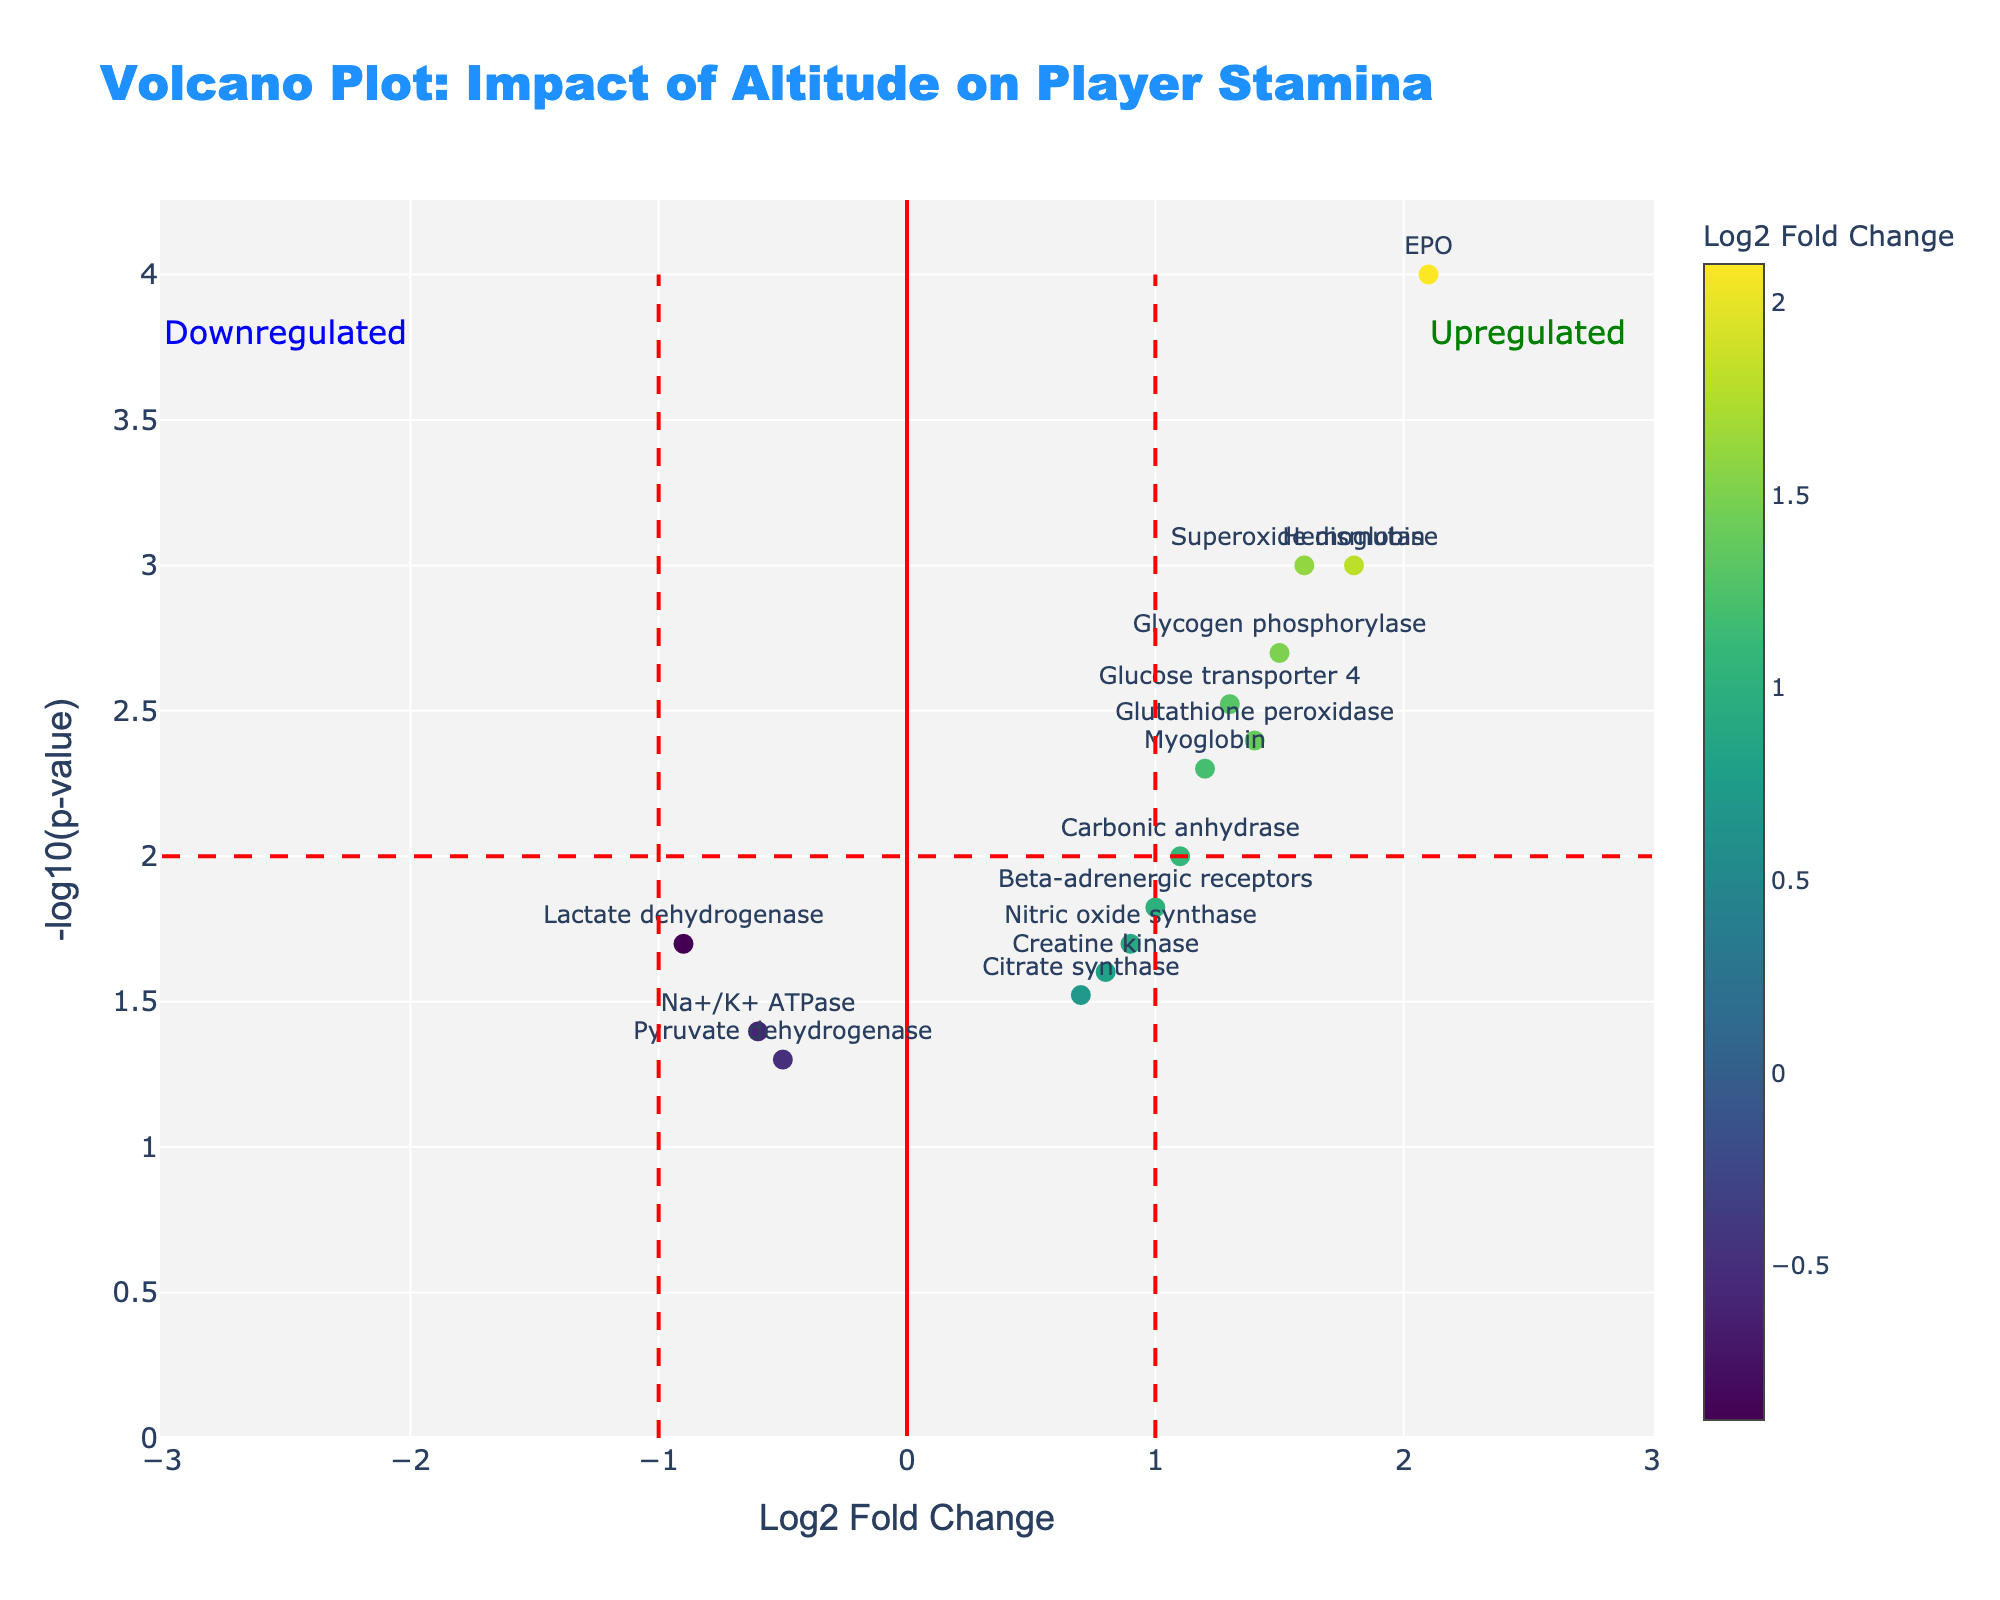Which gene has the highest log2 fold change? To identify the gene with the highest log2 fold change, look for the data point that is farthest to the right on the x-axis. The gene with the highest value is EPO with a log2 fold change of 2.1.
Answer: EPO How many genes are significantly upregulated? Genes are considered significantly upregulated if they are on the right side of the vertical significance line (log2 fold change > 1) and above the horizontal significance line (-log10(p-value) > 2). The upregulated genes here are Hemoglobin, EPO, Glycogen phosphorylase, and Superoxide dismutase.
Answer: 4 Which gene is downregulated and also has one of the higher -log10(p-value) values? To find this, locate the data points on the left side of the x-axis (log2 fold change < -0.5) and check the ones that are also higher on the y-axis (-log10(p-value) > 1). Lactate dehydrogenase fits this criterion with a log2 fold change of -0.9.
Answer: Lactate dehydrogenase What is the range of the -log10(p-value) values on the y-axis? Determine the minimum and maximum values observed on the y-axis for the data points. The values range from approximately 1.3 (for Pyruvate dehydrogenase) to around 4.0 (for EPO).
Answer: 1.3 to 4.0 How does the log2 fold change of Myoglobin compare to Hemoglobin? Find the log2 fold change values for both Myoglobin and Hemoglobin. Myoglobin has a log2 fold change of 1.2 and Hemoglobin has 1.8, meaning Myoglobin's fold change is lower.
Answer: Lower Which gene has a -log10(p-value) closest to 3? Check the y-axis position to find the data point closest to 3. Hemoglobin has a -log10(p-value) around 3.
Answer: Hemoglobin Which gene shows the smallest log2 fold change yet is still statistically significant? Locate the data point with the smallest absolute log2 fold change that lies above the horizontal line for statistical significance. Pyruvate dehydrogenase has a log2 fold change of -0.5 and is deemed statistically significant as its -log10(p-value) is 1.3.
Answer: Pyruvate dehydrogenase Are there any genes with a log2 fold change between 0.5 and 1? Investigate the x-axis for data points that are between 0.5 and 1. Genes that satisfy this are Carbonic anhydrase and Pyruvate dehydrogenase.
Answer: Yes 